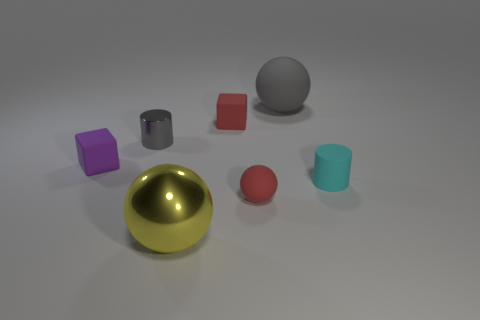Add 1 big purple balls. How many objects exist? 8 Subtract all balls. How many objects are left? 4 Subtract all tiny yellow cubes. Subtract all red matte cubes. How many objects are left? 6 Add 5 rubber cubes. How many rubber cubes are left? 7 Add 4 metallic cylinders. How many metallic cylinders exist? 5 Subtract 0 brown blocks. How many objects are left? 7 